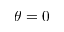Convert formula to latex. <formula><loc_0><loc_0><loc_500><loc_500>\theta = 0</formula> 